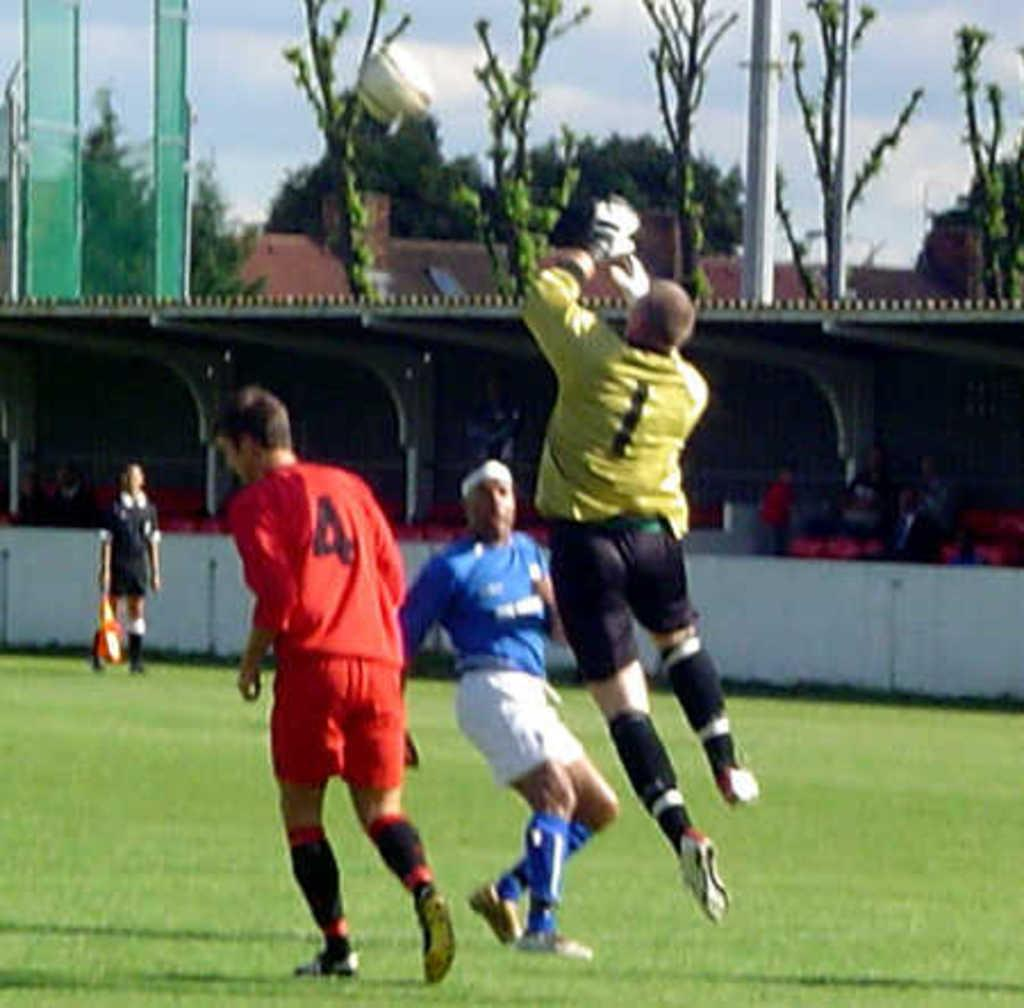Provide a one-sentence caption for the provided image. The footballer in red has the number 4 on his shirt. 